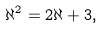<formula> <loc_0><loc_0><loc_500><loc_500>\aleph ^ { 2 } = 2 \aleph + 3 ,</formula> 